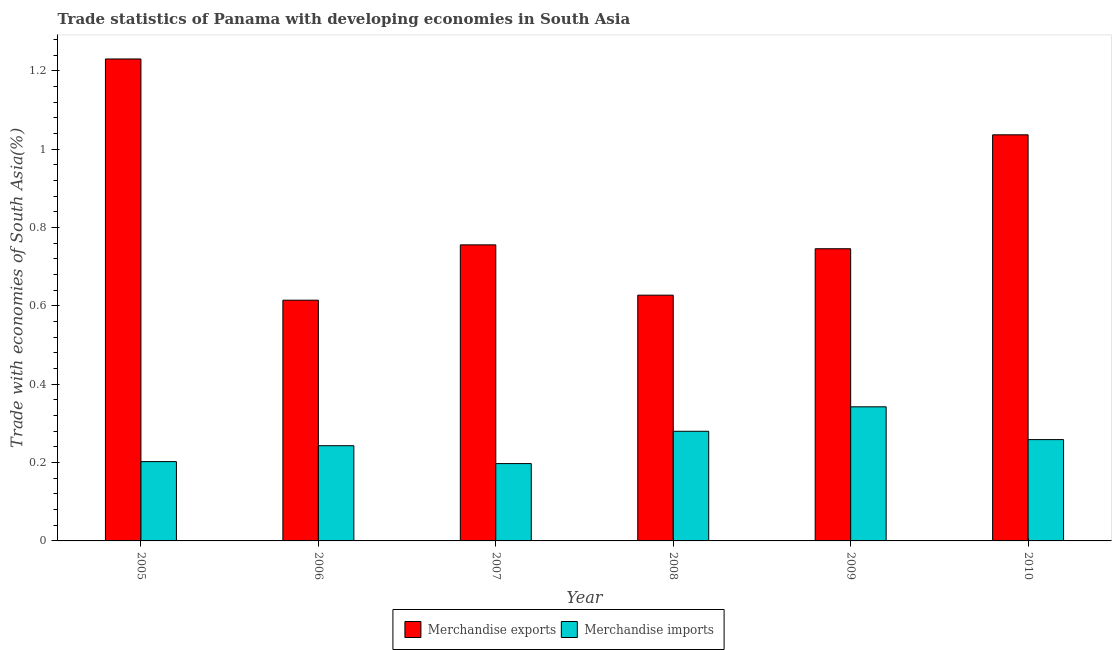How many different coloured bars are there?
Give a very brief answer. 2. How many groups of bars are there?
Offer a terse response. 6. How many bars are there on the 3rd tick from the left?
Make the answer very short. 2. What is the label of the 6th group of bars from the left?
Offer a terse response. 2010. In how many cases, is the number of bars for a given year not equal to the number of legend labels?
Your answer should be compact. 0. What is the merchandise exports in 2006?
Your answer should be compact. 0.61. Across all years, what is the maximum merchandise imports?
Your answer should be very brief. 0.34. Across all years, what is the minimum merchandise imports?
Offer a terse response. 0.2. In which year was the merchandise exports maximum?
Keep it short and to the point. 2005. What is the total merchandise imports in the graph?
Ensure brevity in your answer.  1.52. What is the difference between the merchandise imports in 2009 and that in 2010?
Your answer should be very brief. 0.08. What is the difference between the merchandise imports in 2006 and the merchandise exports in 2008?
Keep it short and to the point. -0.04. What is the average merchandise imports per year?
Offer a terse response. 0.25. In how many years, is the merchandise exports greater than 0.52 %?
Provide a short and direct response. 6. What is the ratio of the merchandise exports in 2005 to that in 2010?
Keep it short and to the point. 1.19. Is the merchandise imports in 2008 less than that in 2009?
Provide a short and direct response. Yes. What is the difference between the highest and the second highest merchandise imports?
Ensure brevity in your answer.  0.06. What is the difference between the highest and the lowest merchandise exports?
Offer a terse response. 0.62. In how many years, is the merchandise imports greater than the average merchandise imports taken over all years?
Ensure brevity in your answer.  3. Is the sum of the merchandise imports in 2005 and 2007 greater than the maximum merchandise exports across all years?
Your answer should be very brief. Yes. How many bars are there?
Offer a terse response. 12. What is the difference between two consecutive major ticks on the Y-axis?
Give a very brief answer. 0.2. How are the legend labels stacked?
Your answer should be compact. Horizontal. What is the title of the graph?
Your answer should be compact. Trade statistics of Panama with developing economies in South Asia. Does "Non-solid fuel" appear as one of the legend labels in the graph?
Your response must be concise. No. What is the label or title of the Y-axis?
Give a very brief answer. Trade with economies of South Asia(%). What is the Trade with economies of South Asia(%) of Merchandise exports in 2005?
Your answer should be very brief. 1.23. What is the Trade with economies of South Asia(%) in Merchandise imports in 2005?
Keep it short and to the point. 0.2. What is the Trade with economies of South Asia(%) of Merchandise exports in 2006?
Provide a succinct answer. 0.61. What is the Trade with economies of South Asia(%) in Merchandise imports in 2006?
Your answer should be very brief. 0.24. What is the Trade with economies of South Asia(%) in Merchandise exports in 2007?
Keep it short and to the point. 0.76. What is the Trade with economies of South Asia(%) in Merchandise imports in 2007?
Your answer should be very brief. 0.2. What is the Trade with economies of South Asia(%) of Merchandise exports in 2008?
Give a very brief answer. 0.63. What is the Trade with economies of South Asia(%) of Merchandise imports in 2008?
Offer a very short reply. 0.28. What is the Trade with economies of South Asia(%) in Merchandise exports in 2009?
Offer a very short reply. 0.75. What is the Trade with economies of South Asia(%) in Merchandise imports in 2009?
Offer a very short reply. 0.34. What is the Trade with economies of South Asia(%) in Merchandise exports in 2010?
Your answer should be very brief. 1.04. What is the Trade with economies of South Asia(%) in Merchandise imports in 2010?
Keep it short and to the point. 0.26. Across all years, what is the maximum Trade with economies of South Asia(%) of Merchandise exports?
Offer a very short reply. 1.23. Across all years, what is the maximum Trade with economies of South Asia(%) of Merchandise imports?
Your response must be concise. 0.34. Across all years, what is the minimum Trade with economies of South Asia(%) of Merchandise exports?
Offer a terse response. 0.61. Across all years, what is the minimum Trade with economies of South Asia(%) in Merchandise imports?
Make the answer very short. 0.2. What is the total Trade with economies of South Asia(%) of Merchandise exports in the graph?
Your response must be concise. 5.01. What is the total Trade with economies of South Asia(%) in Merchandise imports in the graph?
Keep it short and to the point. 1.52. What is the difference between the Trade with economies of South Asia(%) in Merchandise exports in 2005 and that in 2006?
Your response must be concise. 0.62. What is the difference between the Trade with economies of South Asia(%) in Merchandise imports in 2005 and that in 2006?
Provide a succinct answer. -0.04. What is the difference between the Trade with economies of South Asia(%) in Merchandise exports in 2005 and that in 2007?
Your answer should be compact. 0.47. What is the difference between the Trade with economies of South Asia(%) of Merchandise imports in 2005 and that in 2007?
Keep it short and to the point. 0.01. What is the difference between the Trade with economies of South Asia(%) in Merchandise exports in 2005 and that in 2008?
Give a very brief answer. 0.6. What is the difference between the Trade with economies of South Asia(%) of Merchandise imports in 2005 and that in 2008?
Offer a very short reply. -0.08. What is the difference between the Trade with economies of South Asia(%) of Merchandise exports in 2005 and that in 2009?
Offer a very short reply. 0.48. What is the difference between the Trade with economies of South Asia(%) of Merchandise imports in 2005 and that in 2009?
Offer a terse response. -0.14. What is the difference between the Trade with economies of South Asia(%) of Merchandise exports in 2005 and that in 2010?
Offer a very short reply. 0.19. What is the difference between the Trade with economies of South Asia(%) of Merchandise imports in 2005 and that in 2010?
Your answer should be very brief. -0.06. What is the difference between the Trade with economies of South Asia(%) of Merchandise exports in 2006 and that in 2007?
Ensure brevity in your answer.  -0.14. What is the difference between the Trade with economies of South Asia(%) of Merchandise imports in 2006 and that in 2007?
Provide a short and direct response. 0.05. What is the difference between the Trade with economies of South Asia(%) of Merchandise exports in 2006 and that in 2008?
Your response must be concise. -0.01. What is the difference between the Trade with economies of South Asia(%) of Merchandise imports in 2006 and that in 2008?
Your answer should be compact. -0.04. What is the difference between the Trade with economies of South Asia(%) in Merchandise exports in 2006 and that in 2009?
Make the answer very short. -0.13. What is the difference between the Trade with economies of South Asia(%) of Merchandise imports in 2006 and that in 2009?
Ensure brevity in your answer.  -0.1. What is the difference between the Trade with economies of South Asia(%) of Merchandise exports in 2006 and that in 2010?
Your answer should be very brief. -0.42. What is the difference between the Trade with economies of South Asia(%) of Merchandise imports in 2006 and that in 2010?
Provide a succinct answer. -0.02. What is the difference between the Trade with economies of South Asia(%) of Merchandise exports in 2007 and that in 2008?
Keep it short and to the point. 0.13. What is the difference between the Trade with economies of South Asia(%) in Merchandise imports in 2007 and that in 2008?
Offer a very short reply. -0.08. What is the difference between the Trade with economies of South Asia(%) of Merchandise exports in 2007 and that in 2009?
Provide a succinct answer. 0.01. What is the difference between the Trade with economies of South Asia(%) in Merchandise imports in 2007 and that in 2009?
Provide a short and direct response. -0.14. What is the difference between the Trade with economies of South Asia(%) of Merchandise exports in 2007 and that in 2010?
Keep it short and to the point. -0.28. What is the difference between the Trade with economies of South Asia(%) in Merchandise imports in 2007 and that in 2010?
Offer a very short reply. -0.06. What is the difference between the Trade with economies of South Asia(%) of Merchandise exports in 2008 and that in 2009?
Make the answer very short. -0.12. What is the difference between the Trade with economies of South Asia(%) of Merchandise imports in 2008 and that in 2009?
Make the answer very short. -0.06. What is the difference between the Trade with economies of South Asia(%) in Merchandise exports in 2008 and that in 2010?
Provide a succinct answer. -0.41. What is the difference between the Trade with economies of South Asia(%) in Merchandise imports in 2008 and that in 2010?
Keep it short and to the point. 0.02. What is the difference between the Trade with economies of South Asia(%) in Merchandise exports in 2009 and that in 2010?
Provide a short and direct response. -0.29. What is the difference between the Trade with economies of South Asia(%) in Merchandise imports in 2009 and that in 2010?
Ensure brevity in your answer.  0.08. What is the difference between the Trade with economies of South Asia(%) of Merchandise exports in 2005 and the Trade with economies of South Asia(%) of Merchandise imports in 2006?
Make the answer very short. 0.99. What is the difference between the Trade with economies of South Asia(%) in Merchandise exports in 2005 and the Trade with economies of South Asia(%) in Merchandise imports in 2007?
Make the answer very short. 1.03. What is the difference between the Trade with economies of South Asia(%) in Merchandise exports in 2005 and the Trade with economies of South Asia(%) in Merchandise imports in 2008?
Make the answer very short. 0.95. What is the difference between the Trade with economies of South Asia(%) of Merchandise exports in 2005 and the Trade with economies of South Asia(%) of Merchandise imports in 2009?
Your answer should be very brief. 0.89. What is the difference between the Trade with economies of South Asia(%) in Merchandise exports in 2005 and the Trade with economies of South Asia(%) in Merchandise imports in 2010?
Keep it short and to the point. 0.97. What is the difference between the Trade with economies of South Asia(%) of Merchandise exports in 2006 and the Trade with economies of South Asia(%) of Merchandise imports in 2007?
Keep it short and to the point. 0.42. What is the difference between the Trade with economies of South Asia(%) of Merchandise exports in 2006 and the Trade with economies of South Asia(%) of Merchandise imports in 2008?
Your answer should be compact. 0.33. What is the difference between the Trade with economies of South Asia(%) of Merchandise exports in 2006 and the Trade with economies of South Asia(%) of Merchandise imports in 2009?
Provide a short and direct response. 0.27. What is the difference between the Trade with economies of South Asia(%) of Merchandise exports in 2006 and the Trade with economies of South Asia(%) of Merchandise imports in 2010?
Offer a very short reply. 0.36. What is the difference between the Trade with economies of South Asia(%) of Merchandise exports in 2007 and the Trade with economies of South Asia(%) of Merchandise imports in 2008?
Your answer should be compact. 0.48. What is the difference between the Trade with economies of South Asia(%) of Merchandise exports in 2007 and the Trade with economies of South Asia(%) of Merchandise imports in 2009?
Provide a short and direct response. 0.41. What is the difference between the Trade with economies of South Asia(%) of Merchandise exports in 2007 and the Trade with economies of South Asia(%) of Merchandise imports in 2010?
Give a very brief answer. 0.5. What is the difference between the Trade with economies of South Asia(%) of Merchandise exports in 2008 and the Trade with economies of South Asia(%) of Merchandise imports in 2009?
Keep it short and to the point. 0.28. What is the difference between the Trade with economies of South Asia(%) of Merchandise exports in 2008 and the Trade with economies of South Asia(%) of Merchandise imports in 2010?
Your answer should be very brief. 0.37. What is the difference between the Trade with economies of South Asia(%) in Merchandise exports in 2009 and the Trade with economies of South Asia(%) in Merchandise imports in 2010?
Offer a terse response. 0.49. What is the average Trade with economies of South Asia(%) in Merchandise exports per year?
Give a very brief answer. 0.83. What is the average Trade with economies of South Asia(%) of Merchandise imports per year?
Offer a terse response. 0.25. In the year 2005, what is the difference between the Trade with economies of South Asia(%) of Merchandise exports and Trade with economies of South Asia(%) of Merchandise imports?
Keep it short and to the point. 1.03. In the year 2006, what is the difference between the Trade with economies of South Asia(%) of Merchandise exports and Trade with economies of South Asia(%) of Merchandise imports?
Your response must be concise. 0.37. In the year 2007, what is the difference between the Trade with economies of South Asia(%) of Merchandise exports and Trade with economies of South Asia(%) of Merchandise imports?
Provide a short and direct response. 0.56. In the year 2008, what is the difference between the Trade with economies of South Asia(%) of Merchandise exports and Trade with economies of South Asia(%) of Merchandise imports?
Ensure brevity in your answer.  0.35. In the year 2009, what is the difference between the Trade with economies of South Asia(%) in Merchandise exports and Trade with economies of South Asia(%) in Merchandise imports?
Your answer should be very brief. 0.4. What is the ratio of the Trade with economies of South Asia(%) in Merchandise exports in 2005 to that in 2006?
Offer a very short reply. 2. What is the ratio of the Trade with economies of South Asia(%) in Merchandise imports in 2005 to that in 2006?
Keep it short and to the point. 0.83. What is the ratio of the Trade with economies of South Asia(%) in Merchandise exports in 2005 to that in 2007?
Ensure brevity in your answer.  1.63. What is the ratio of the Trade with economies of South Asia(%) of Merchandise imports in 2005 to that in 2007?
Keep it short and to the point. 1.03. What is the ratio of the Trade with economies of South Asia(%) in Merchandise exports in 2005 to that in 2008?
Make the answer very short. 1.96. What is the ratio of the Trade with economies of South Asia(%) of Merchandise imports in 2005 to that in 2008?
Keep it short and to the point. 0.72. What is the ratio of the Trade with economies of South Asia(%) in Merchandise exports in 2005 to that in 2009?
Provide a succinct answer. 1.65. What is the ratio of the Trade with economies of South Asia(%) of Merchandise imports in 2005 to that in 2009?
Offer a terse response. 0.59. What is the ratio of the Trade with economies of South Asia(%) in Merchandise exports in 2005 to that in 2010?
Your answer should be very brief. 1.19. What is the ratio of the Trade with economies of South Asia(%) of Merchandise imports in 2005 to that in 2010?
Your answer should be compact. 0.78. What is the ratio of the Trade with economies of South Asia(%) of Merchandise exports in 2006 to that in 2007?
Provide a succinct answer. 0.81. What is the ratio of the Trade with economies of South Asia(%) in Merchandise imports in 2006 to that in 2007?
Offer a very short reply. 1.23. What is the ratio of the Trade with economies of South Asia(%) of Merchandise exports in 2006 to that in 2008?
Make the answer very short. 0.98. What is the ratio of the Trade with economies of South Asia(%) in Merchandise imports in 2006 to that in 2008?
Provide a short and direct response. 0.87. What is the ratio of the Trade with economies of South Asia(%) of Merchandise exports in 2006 to that in 2009?
Ensure brevity in your answer.  0.82. What is the ratio of the Trade with economies of South Asia(%) in Merchandise imports in 2006 to that in 2009?
Your answer should be very brief. 0.71. What is the ratio of the Trade with economies of South Asia(%) in Merchandise exports in 2006 to that in 2010?
Your response must be concise. 0.59. What is the ratio of the Trade with economies of South Asia(%) in Merchandise imports in 2006 to that in 2010?
Offer a terse response. 0.94. What is the ratio of the Trade with economies of South Asia(%) of Merchandise exports in 2007 to that in 2008?
Your answer should be very brief. 1.2. What is the ratio of the Trade with economies of South Asia(%) of Merchandise imports in 2007 to that in 2008?
Offer a very short reply. 0.71. What is the ratio of the Trade with economies of South Asia(%) of Merchandise exports in 2007 to that in 2009?
Ensure brevity in your answer.  1.01. What is the ratio of the Trade with economies of South Asia(%) of Merchandise imports in 2007 to that in 2009?
Keep it short and to the point. 0.58. What is the ratio of the Trade with economies of South Asia(%) in Merchandise exports in 2007 to that in 2010?
Give a very brief answer. 0.73. What is the ratio of the Trade with economies of South Asia(%) in Merchandise imports in 2007 to that in 2010?
Keep it short and to the point. 0.76. What is the ratio of the Trade with economies of South Asia(%) of Merchandise exports in 2008 to that in 2009?
Offer a very short reply. 0.84. What is the ratio of the Trade with economies of South Asia(%) in Merchandise imports in 2008 to that in 2009?
Offer a very short reply. 0.82. What is the ratio of the Trade with economies of South Asia(%) in Merchandise exports in 2008 to that in 2010?
Your answer should be compact. 0.61. What is the ratio of the Trade with economies of South Asia(%) of Merchandise imports in 2008 to that in 2010?
Keep it short and to the point. 1.08. What is the ratio of the Trade with economies of South Asia(%) in Merchandise exports in 2009 to that in 2010?
Provide a short and direct response. 0.72. What is the ratio of the Trade with economies of South Asia(%) of Merchandise imports in 2009 to that in 2010?
Keep it short and to the point. 1.32. What is the difference between the highest and the second highest Trade with economies of South Asia(%) in Merchandise exports?
Your answer should be compact. 0.19. What is the difference between the highest and the second highest Trade with economies of South Asia(%) of Merchandise imports?
Offer a terse response. 0.06. What is the difference between the highest and the lowest Trade with economies of South Asia(%) of Merchandise exports?
Provide a short and direct response. 0.62. What is the difference between the highest and the lowest Trade with economies of South Asia(%) in Merchandise imports?
Provide a short and direct response. 0.14. 